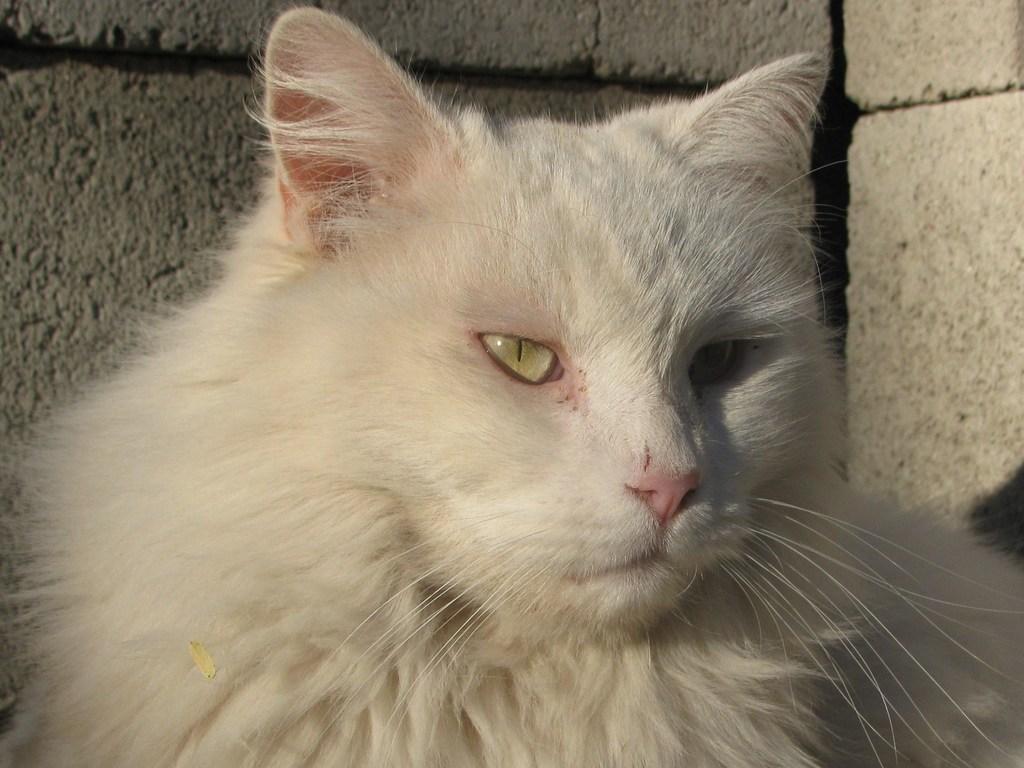Please provide a concise description of this image. In this image in front there is a white cat. Behind the white cat there are bricks. 